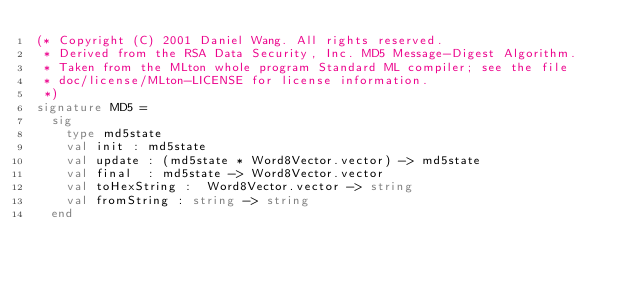<code> <loc_0><loc_0><loc_500><loc_500><_SML_>(* Copyright (C) 2001 Daniel Wang. All rights reserved.
 * Derived from the RSA Data Security, Inc. MD5 Message-Digest Algorithm.
 * Taken from the MLton whole program Standard ML compiler; see the file
 * doc/license/MLton-LICENSE for license information.
 *)
signature MD5 =
  sig
    type md5state
    val init : md5state
    val update : (md5state * Word8Vector.vector) -> md5state
    val final  : md5state -> Word8Vector.vector
    val toHexString :  Word8Vector.vector -> string
    val fromString : string -> string
  end
</code> 